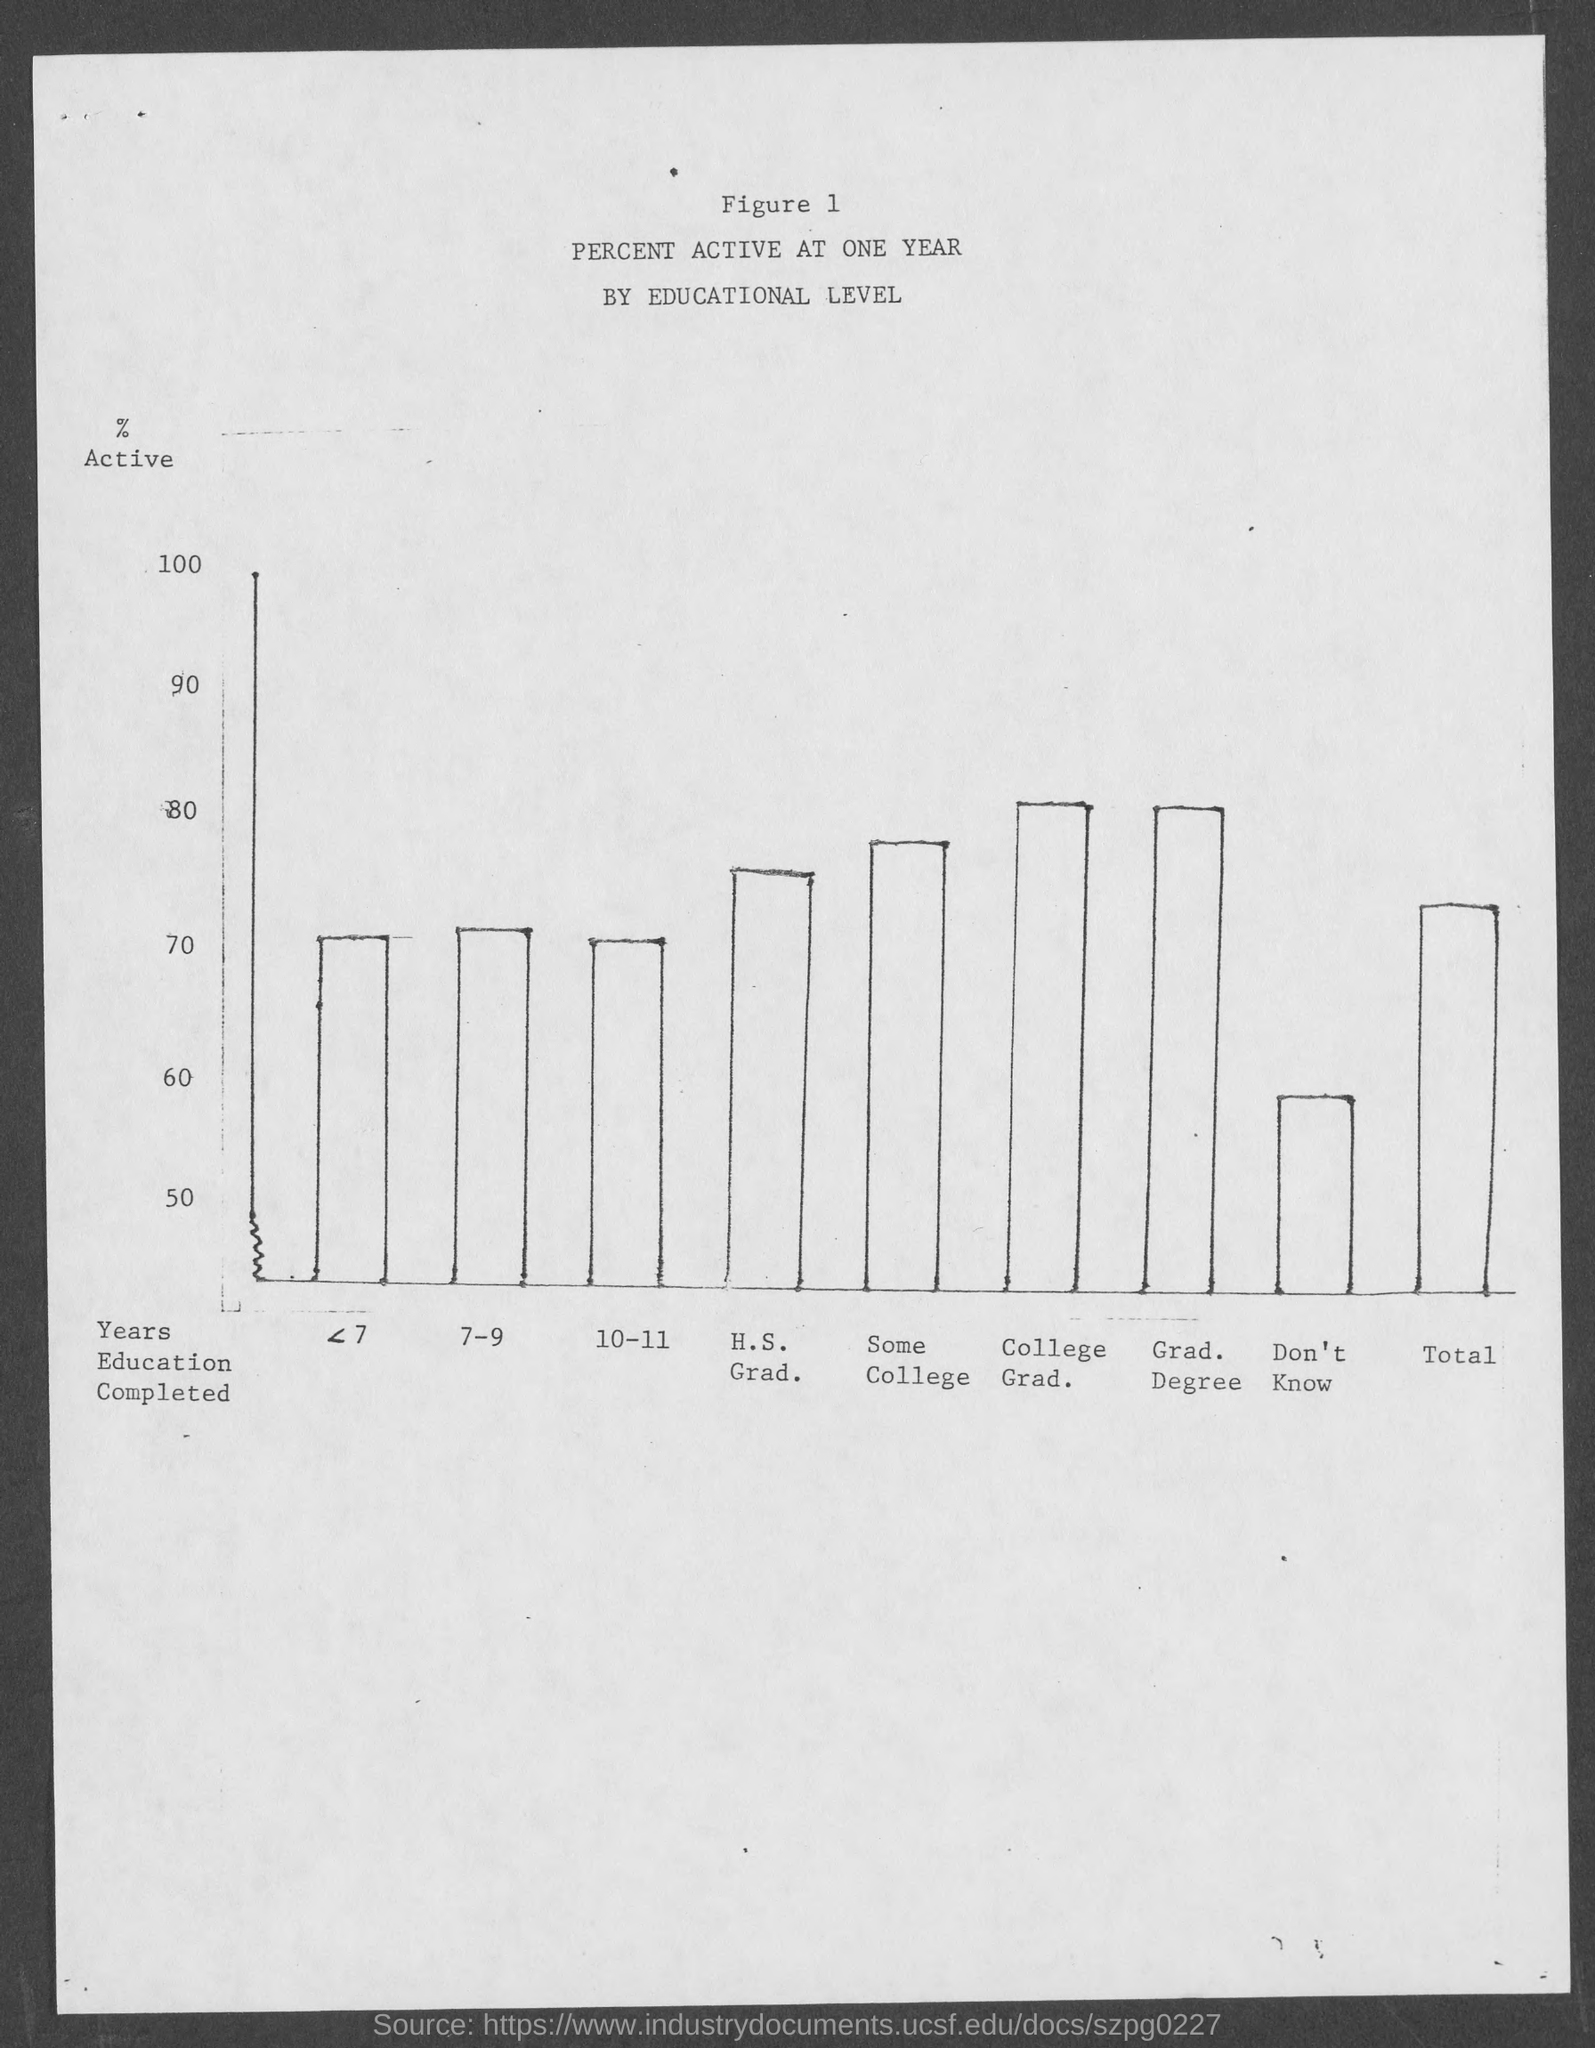Specify some key components in this picture. The title of this study is 'Percent Active at One Year by Educational Level.' The figure number is 1 and counting. 